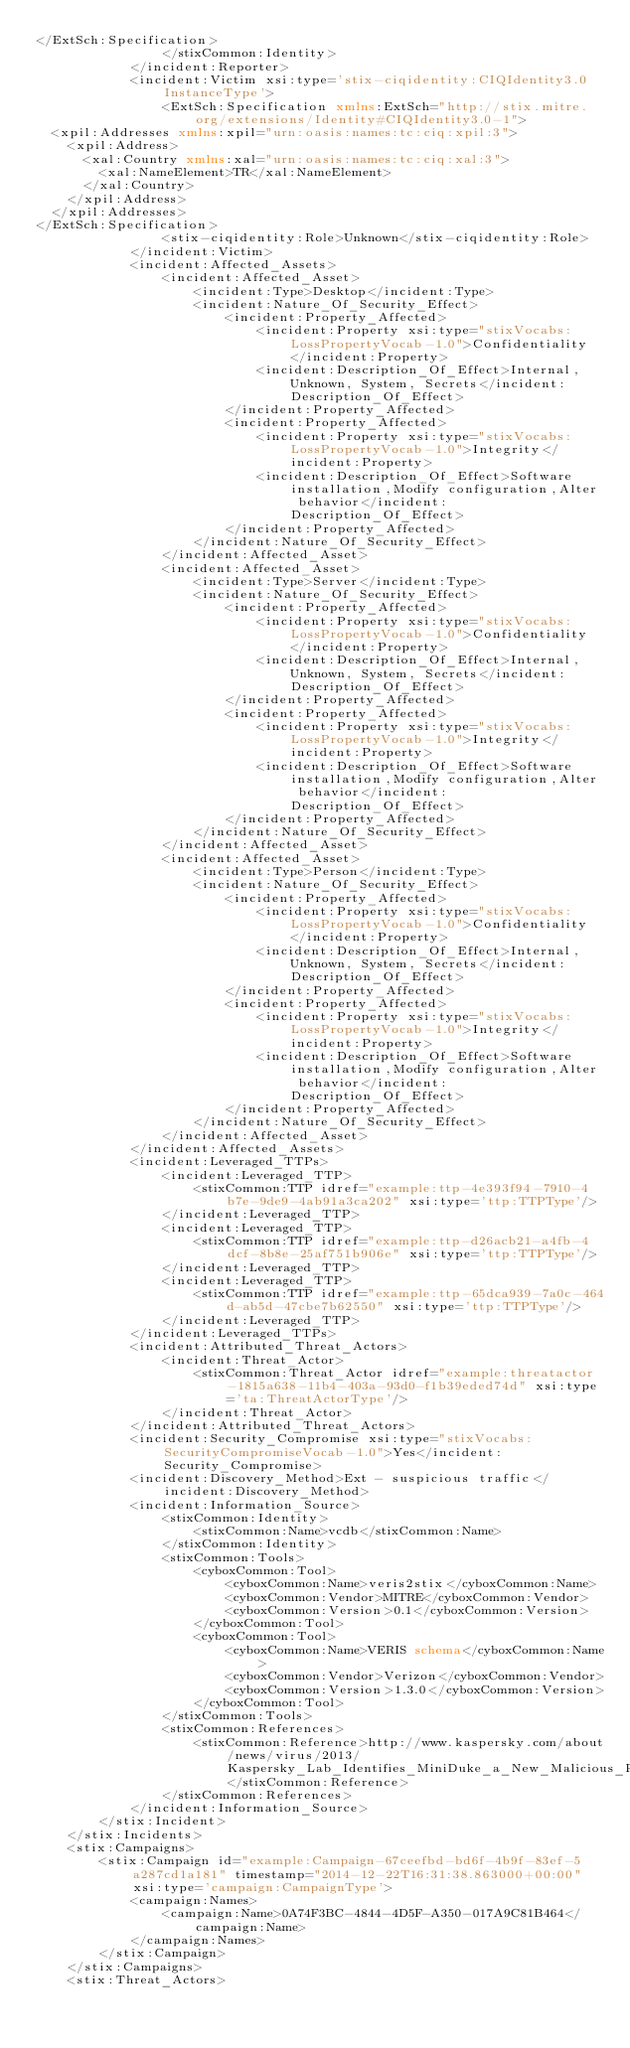<code> <loc_0><loc_0><loc_500><loc_500><_XML_></ExtSch:Specification>
                </stixCommon:Identity>
            </incident:Reporter>
            <incident:Victim xsi:type='stix-ciqidentity:CIQIdentity3.0InstanceType'>
                <ExtSch:Specification xmlns:ExtSch="http://stix.mitre.org/extensions/Identity#CIQIdentity3.0-1">
  <xpil:Addresses xmlns:xpil="urn:oasis:names:tc:ciq:xpil:3">
    <xpil:Address>
      <xal:Country xmlns:xal="urn:oasis:names:tc:ciq:xal:3">
        <xal:NameElement>TR</xal:NameElement>
      </xal:Country>
    </xpil:Address>
  </xpil:Addresses>
</ExtSch:Specification>
                <stix-ciqidentity:Role>Unknown</stix-ciqidentity:Role>
            </incident:Victim>
            <incident:Affected_Assets>
                <incident:Affected_Asset>
                    <incident:Type>Desktop</incident:Type>
                    <incident:Nature_Of_Security_Effect>
                        <incident:Property_Affected>
                            <incident:Property xsi:type="stixVocabs:LossPropertyVocab-1.0">Confidentiality</incident:Property>
                            <incident:Description_Of_Effect>Internal, Unknown, System, Secrets</incident:Description_Of_Effect>
                        </incident:Property_Affected>
                        <incident:Property_Affected>
                            <incident:Property xsi:type="stixVocabs:LossPropertyVocab-1.0">Integrity</incident:Property>
                            <incident:Description_Of_Effect>Software installation,Modify configuration,Alter behavior</incident:Description_Of_Effect>
                        </incident:Property_Affected>
                    </incident:Nature_Of_Security_Effect>
                </incident:Affected_Asset>
                <incident:Affected_Asset>
                    <incident:Type>Server</incident:Type>
                    <incident:Nature_Of_Security_Effect>
                        <incident:Property_Affected>
                            <incident:Property xsi:type="stixVocabs:LossPropertyVocab-1.0">Confidentiality</incident:Property>
                            <incident:Description_Of_Effect>Internal, Unknown, System, Secrets</incident:Description_Of_Effect>
                        </incident:Property_Affected>
                        <incident:Property_Affected>
                            <incident:Property xsi:type="stixVocabs:LossPropertyVocab-1.0">Integrity</incident:Property>
                            <incident:Description_Of_Effect>Software installation,Modify configuration,Alter behavior</incident:Description_Of_Effect>
                        </incident:Property_Affected>
                    </incident:Nature_Of_Security_Effect>
                </incident:Affected_Asset>
                <incident:Affected_Asset>
                    <incident:Type>Person</incident:Type>
                    <incident:Nature_Of_Security_Effect>
                        <incident:Property_Affected>
                            <incident:Property xsi:type="stixVocabs:LossPropertyVocab-1.0">Confidentiality</incident:Property>
                            <incident:Description_Of_Effect>Internal, Unknown, System, Secrets</incident:Description_Of_Effect>
                        </incident:Property_Affected>
                        <incident:Property_Affected>
                            <incident:Property xsi:type="stixVocabs:LossPropertyVocab-1.0">Integrity</incident:Property>
                            <incident:Description_Of_Effect>Software installation,Modify configuration,Alter behavior</incident:Description_Of_Effect>
                        </incident:Property_Affected>
                    </incident:Nature_Of_Security_Effect>
                </incident:Affected_Asset>
            </incident:Affected_Assets>
            <incident:Leveraged_TTPs>
                <incident:Leveraged_TTP>
                    <stixCommon:TTP idref="example:ttp-4e393f94-7910-4b7e-9de9-4ab91a3ca202" xsi:type='ttp:TTPType'/>
                </incident:Leveraged_TTP>
                <incident:Leveraged_TTP>
                    <stixCommon:TTP idref="example:ttp-d26acb21-a4fb-4dcf-8b8e-25af751b906e" xsi:type='ttp:TTPType'/>
                </incident:Leveraged_TTP>
                <incident:Leveraged_TTP>
                    <stixCommon:TTP idref="example:ttp-65dca939-7a0c-464d-ab5d-47cbe7b62550" xsi:type='ttp:TTPType'/>
                </incident:Leveraged_TTP>
            </incident:Leveraged_TTPs>
            <incident:Attributed_Threat_Actors>
                <incident:Threat_Actor>
                    <stixCommon:Threat_Actor idref="example:threatactor-1815a638-11b4-403a-93d0-f1b39eded74d" xsi:type='ta:ThreatActorType'/>
                </incident:Threat_Actor>
            </incident:Attributed_Threat_Actors>
            <incident:Security_Compromise xsi:type="stixVocabs:SecurityCompromiseVocab-1.0">Yes</incident:Security_Compromise>
            <incident:Discovery_Method>Ext - suspicious traffic</incident:Discovery_Method>
            <incident:Information_Source>
                <stixCommon:Identity>
                    <stixCommon:Name>vcdb</stixCommon:Name>
                </stixCommon:Identity>
                <stixCommon:Tools>
                    <cyboxCommon:Tool>
                        <cyboxCommon:Name>veris2stix</cyboxCommon:Name>
                        <cyboxCommon:Vendor>MITRE</cyboxCommon:Vendor>
                        <cyboxCommon:Version>0.1</cyboxCommon:Version>
                    </cyboxCommon:Tool>
                    <cyboxCommon:Tool>
                        <cyboxCommon:Name>VERIS schema</cyboxCommon:Name>
                        <cyboxCommon:Vendor>Verizon</cyboxCommon:Vendor>
                        <cyboxCommon:Version>1.3.0</cyboxCommon:Version>
                    </cyboxCommon:Tool>
                </stixCommon:Tools>
                <stixCommon:References>
                    <stixCommon:Reference>http://www.kaspersky.com/about/news/virus/2013/Kaspersky_Lab_Identifies_MiniDuke_a_New_Malicious_Program_Designed_for_Spying_on_Multiple_Government_Entities_and_Institutions_Across_the_World</stixCommon:Reference>
                </stixCommon:References>
            </incident:Information_Source>
        </stix:Incident>
    </stix:Incidents>
    <stix:Campaigns>
        <stix:Campaign id="example:Campaign-67ceefbd-bd6f-4b9f-83ef-5a287cd1a181" timestamp="2014-12-22T16:31:38.863000+00:00" xsi:type='campaign:CampaignType'>
            <campaign:Names>
                <campaign:Name>0A74F3BC-4844-4D5F-A350-017A9C81B464</campaign:Name>
            </campaign:Names>
        </stix:Campaign>
    </stix:Campaigns>
    <stix:Threat_Actors></code> 